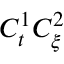<formula> <loc_0><loc_0><loc_500><loc_500>C _ { t } ^ { 1 } C _ { \xi } ^ { 2 }</formula> 